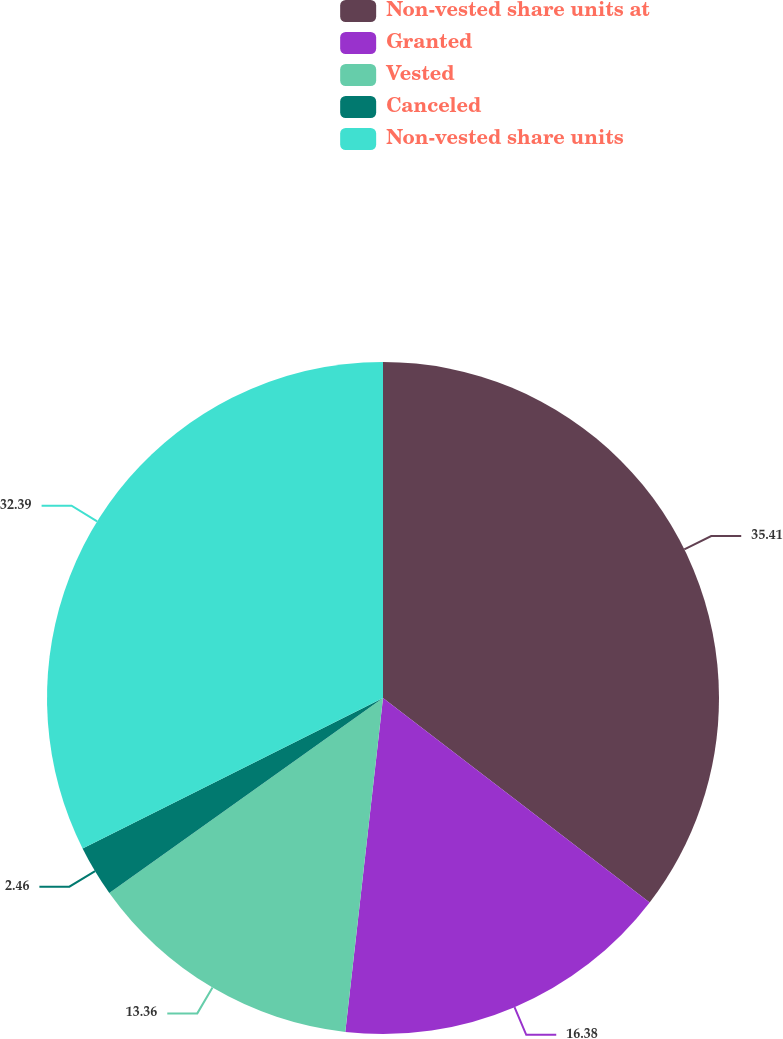<chart> <loc_0><loc_0><loc_500><loc_500><pie_chart><fcel>Non-vested share units at<fcel>Granted<fcel>Vested<fcel>Canceled<fcel>Non-vested share units<nl><fcel>35.41%<fcel>16.38%<fcel>13.36%<fcel>2.46%<fcel>32.39%<nl></chart> 